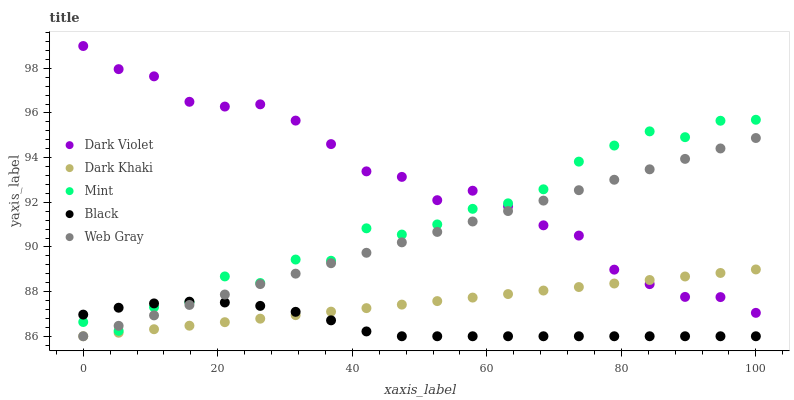Does Black have the minimum area under the curve?
Answer yes or no. Yes. Does Dark Violet have the maximum area under the curve?
Answer yes or no. Yes. Does Web Gray have the minimum area under the curve?
Answer yes or no. No. Does Web Gray have the maximum area under the curve?
Answer yes or no. No. Is Web Gray the smoothest?
Answer yes or no. Yes. Is Mint the roughest?
Answer yes or no. Yes. Is Black the smoothest?
Answer yes or no. No. Is Black the roughest?
Answer yes or no. No. Does Dark Khaki have the lowest value?
Answer yes or no. Yes. Does Mint have the lowest value?
Answer yes or no. No. Does Dark Violet have the highest value?
Answer yes or no. Yes. Does Web Gray have the highest value?
Answer yes or no. No. Is Dark Khaki less than Mint?
Answer yes or no. Yes. Is Mint greater than Dark Khaki?
Answer yes or no. Yes. Does Dark Khaki intersect Black?
Answer yes or no. Yes. Is Dark Khaki less than Black?
Answer yes or no. No. Is Dark Khaki greater than Black?
Answer yes or no. No. Does Dark Khaki intersect Mint?
Answer yes or no. No. 